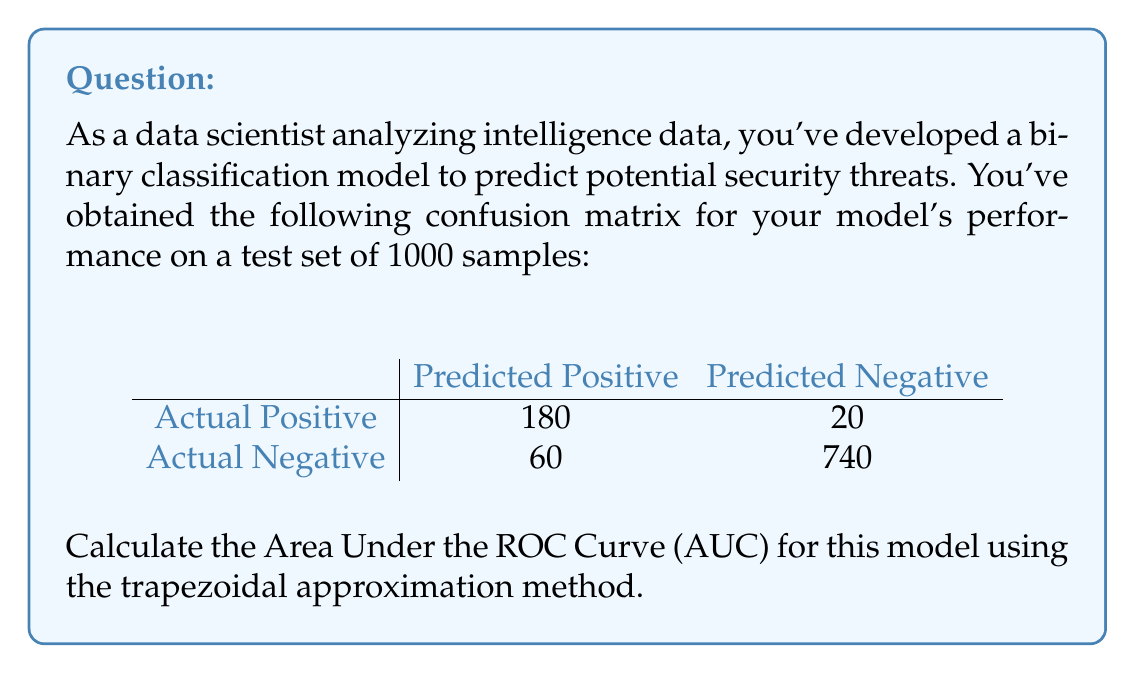Help me with this question. To calculate the AUC using the trapezoidal approximation method, we need to follow these steps:

1. Calculate True Positive Rate (TPR) and False Positive Rate (FPR):

   TPR = True Positives / (True Positives + False Negatives)
   FPR = False Positives / (False Positives + True Negatives)

   From the confusion matrix:
   True Positives (TP) = 180
   False Negatives (FN) = 20
   False Positives (FP) = 60
   True Negatives (TN) = 740

   TPR = 180 / (180 + 20) = 0.9
   FPR = 60 / (60 + 740) = 0.075

2. We now have two points on the ROC curve: (0, 0) and (FPR, TPR), which is (0.075, 0.9).

3. The trapezoidal approximation of the AUC is given by:

   $$ AUC \approx \frac{1}{2} \times (FPR - 0) \times (TPR + 0) + \frac{1}{2} \times (1 - FPR) \times (1 + TPR) $$

4. Substituting the values:

   $$ AUC \approx \frac{1}{2} \times 0.075 \times 0.9 + \frac{1}{2} \times (1 - 0.075) \times (1 + 0.9) $$

5. Calculating:

   $$ AUC \approx 0.03375 + 0.87075 = 0.9045 $$

Therefore, the estimated AUC for this model is approximately 0.9045.
Answer: 0.9045 